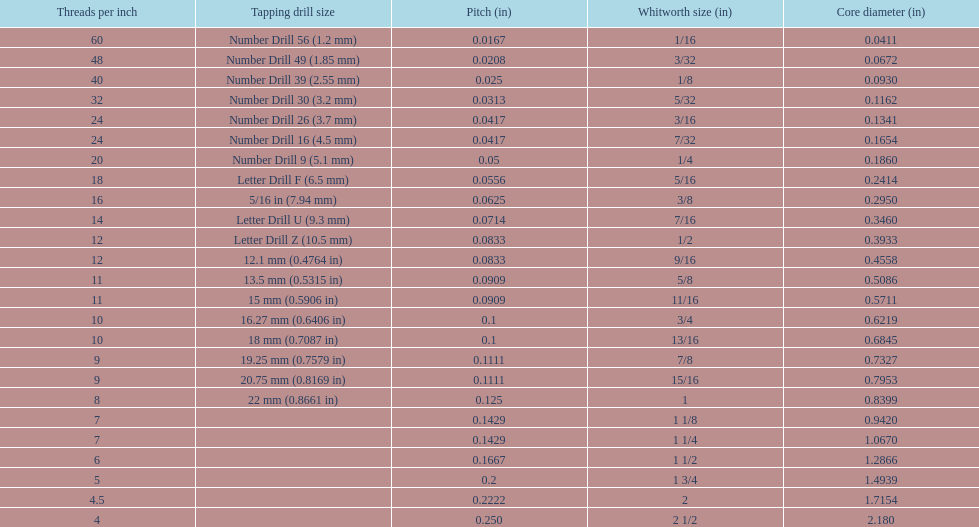What is the core diameter of the first 1/8 whitworth size (in)? 0.0930. 